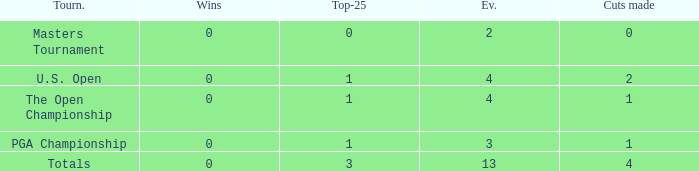How many cuts did he make in the tournament with 3 top 25s and under 13 events? None. 